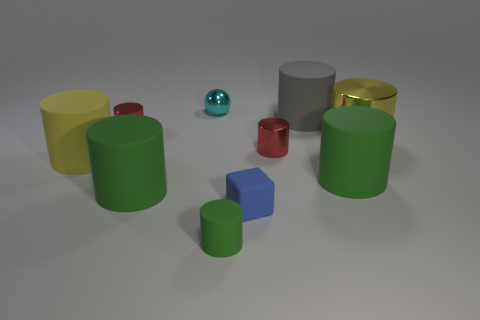What shape is the tiny green object that is made of the same material as the blue block?
Offer a very short reply. Cylinder. There is a yellow object that is right of the small blue block; is it the same shape as the large yellow rubber thing?
Ensure brevity in your answer.  Yes. What number of things are big cylinders or tiny green rubber things?
Keep it short and to the point. 6. What is the tiny cylinder that is in front of the big metallic object and behind the yellow matte cylinder made of?
Your response must be concise. Metal. Does the yellow matte cylinder have the same size as the matte cube?
Make the answer very short. No. There is a red object that is left of the red thing that is in front of the big yellow shiny object; what size is it?
Give a very brief answer. Small. How many small metallic objects are right of the small green cylinder and behind the gray matte object?
Give a very brief answer. 0. There is a tiny object that is behind the tiny red thing that is on the left side of the tiny shiny sphere; is there a tiny green rubber cylinder to the left of it?
Your answer should be compact. No. What is the shape of the gray rubber object that is the same size as the yellow matte cylinder?
Make the answer very short. Cylinder. Is there a large matte cylinder that has the same color as the big metallic cylinder?
Make the answer very short. Yes. 